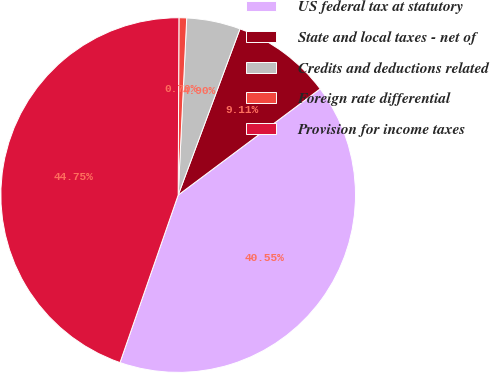Convert chart. <chart><loc_0><loc_0><loc_500><loc_500><pie_chart><fcel>US federal tax at statutory<fcel>State and local taxes - net of<fcel>Credits and deductions related<fcel>Foreign rate differential<fcel>Provision for income taxes<nl><fcel>40.55%<fcel>9.11%<fcel>4.9%<fcel>0.7%<fcel>44.75%<nl></chart> 